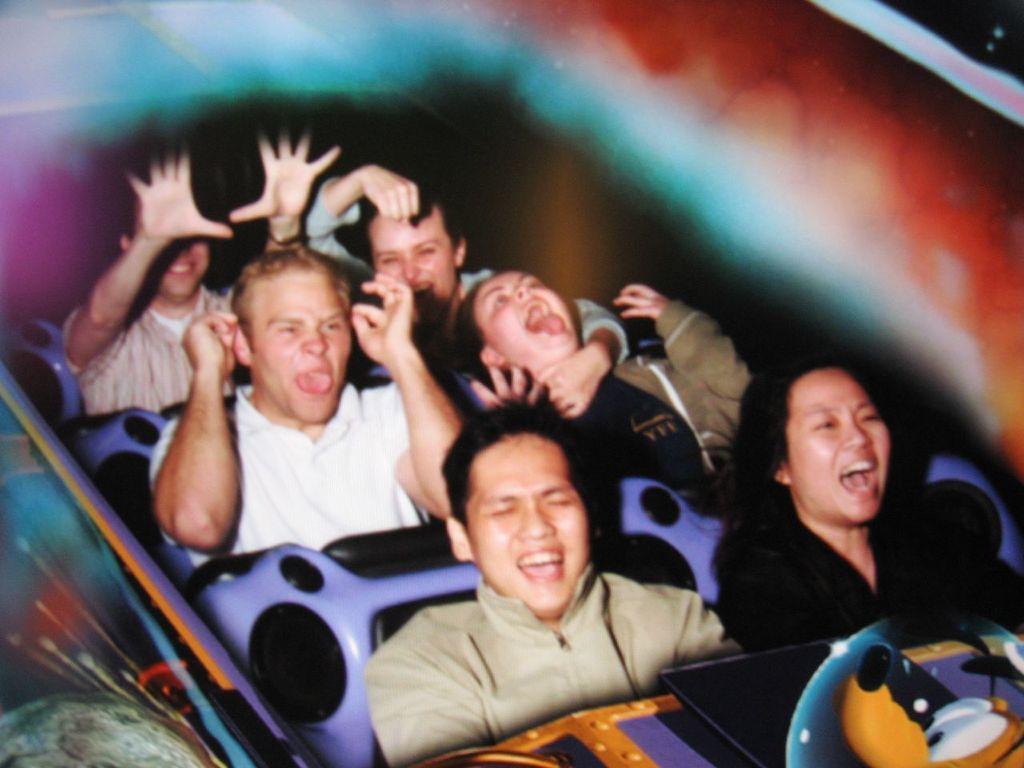Describe this image in one or two sentences. Here I can see a few people are sitting in a roller coaster and laughing. The background is blurred. 